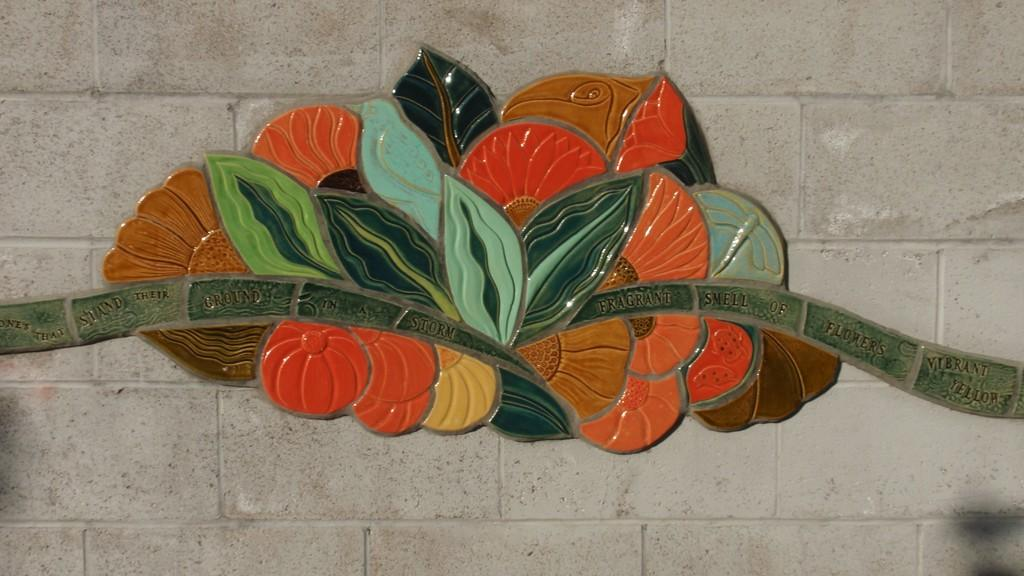What is the main subject of the image? There is a colorful object in the image. What else is present in the image besides the colorful object? There is text on a stone wall in the image. How many baseballs can be seen in the image? There are no baseballs present in the image. What type of pig is depicted on the stone wall in the image? There is no pig depicted on the stone wall in the image; it features text instead. 